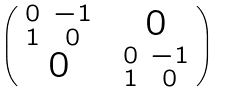Convert formula to latex. <formula><loc_0><loc_0><loc_500><loc_500>\begin{pmatrix} \begin{smallmatrix} 0 & - 1 \\ 1 & 0 \end{smallmatrix} & 0 \\ 0 & \begin{smallmatrix} 0 & - 1 \\ 1 & 0 \end{smallmatrix} \end{pmatrix}</formula> 